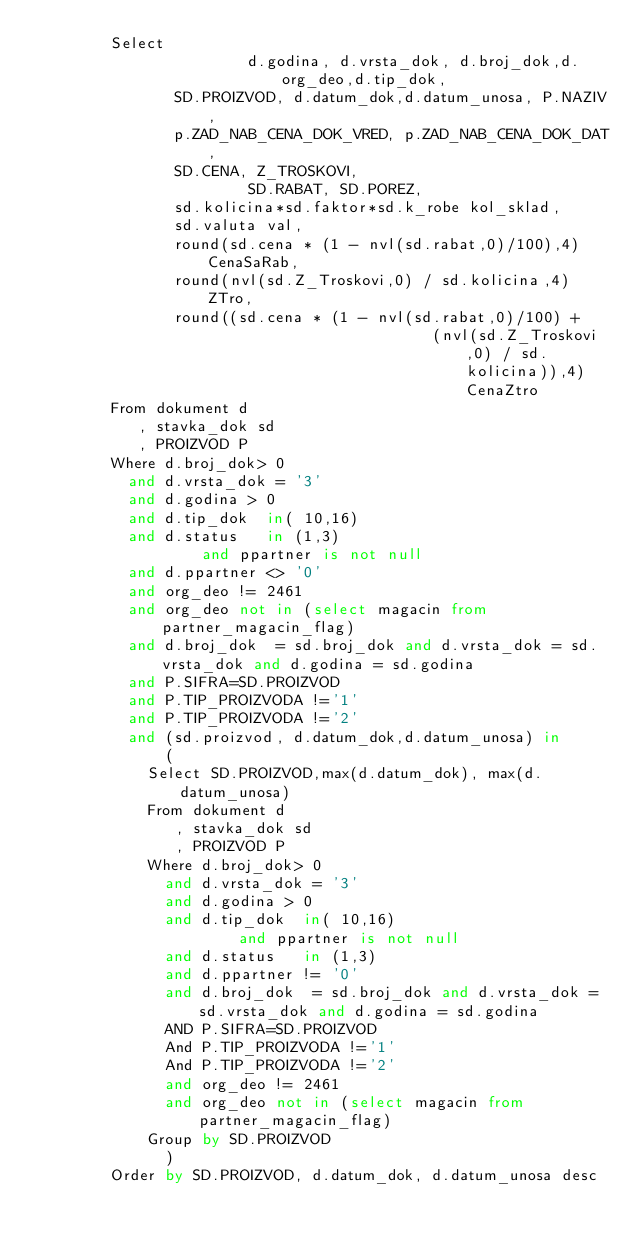<code> <loc_0><loc_0><loc_500><loc_500><_SQL_>				Select
                       d.godina, d.vrsta_dok, d.broj_dok,d.org_deo,d.tip_dok,
				       SD.PROIZVOD, d.datum_dok,d.datum_unosa, P.NAZIV,
				       p.ZAD_NAB_CENA_DOK_VRED, p.ZAD_NAB_CENA_DOK_DAT,
				       SD.CENA, Z_TROSKOVI,
                       SD.RABAT, SD.POREZ, 
				       sd.kolicina*sd.faktor*sd.k_robe kol_sklad,
				       sd.valuta val,
				       round(sd.cena * (1 - nvl(sd.rabat,0)/100),4) CenaSaRab,
				       round(nvl(sd.Z_Troskovi,0) / sd.kolicina,4) ZTro,
				       round((sd.cena * (1 - nvl(sd.rabat,0)/100) +
				                                   (nvl(sd.Z_Troskovi,0) / sd.kolicina)),4) CenaZtro
				From dokument d
				   , stavka_dok sd
				   , PROIZVOD P
				Where d.broj_dok> 0
				  and d.vrsta_dok = '3'
				  and d.godina > 0
				  and d.tip_dok  in( 10,16)
				  and d.status   in (1,3)
                  and ppartner is not null
				  and d.ppartner <> '0'
				  and org_deo != 2461
				  and org_deo not in (select magacin from partner_magacin_flag)
				  and d.broj_dok  = sd.broj_dok and d.vrsta_dok = sd.vrsta_dok and d.godina = sd.godina
				  and P.SIFRA=SD.PROIZVOD
				  and P.TIP_PROIZVODA !='1'
				  and P.TIP_PROIZVODA !='2'
				  and (sd.proizvod, d.datum_dok,d.datum_unosa) in
				      (
						Select SD.PROIZVOD,max(d.datum_dok), max(d.datum_unosa)
						From dokument d
						   , stavka_dok sd
						   , PROIZVOD P
						Where d.broj_dok> 0
						  and d.vrsta_dok = '3'
						  and d.godina > 0
						  and d.tip_dok  in( 10,16)
		                  and ppartner is not null
						  and d.status   in (1,3)
						  and d.ppartner != '0'
						  and d.broj_dok  = sd.broj_dok and d.vrsta_dok = sd.vrsta_dok and d.godina = sd.godina
						  AND P.SIFRA=SD.PROIZVOD
						  And P.TIP_PROIZVODA !='1'
						  And P.TIP_PROIZVODA !='2'
						  and org_deo != 2461
						  and org_deo not in (select magacin from partner_magacin_flag)
						Group by SD.PROIZVOD
				      )
				Order by SD.PROIZVOD, d.datum_dok, d.datum_unosa desc
</code> 